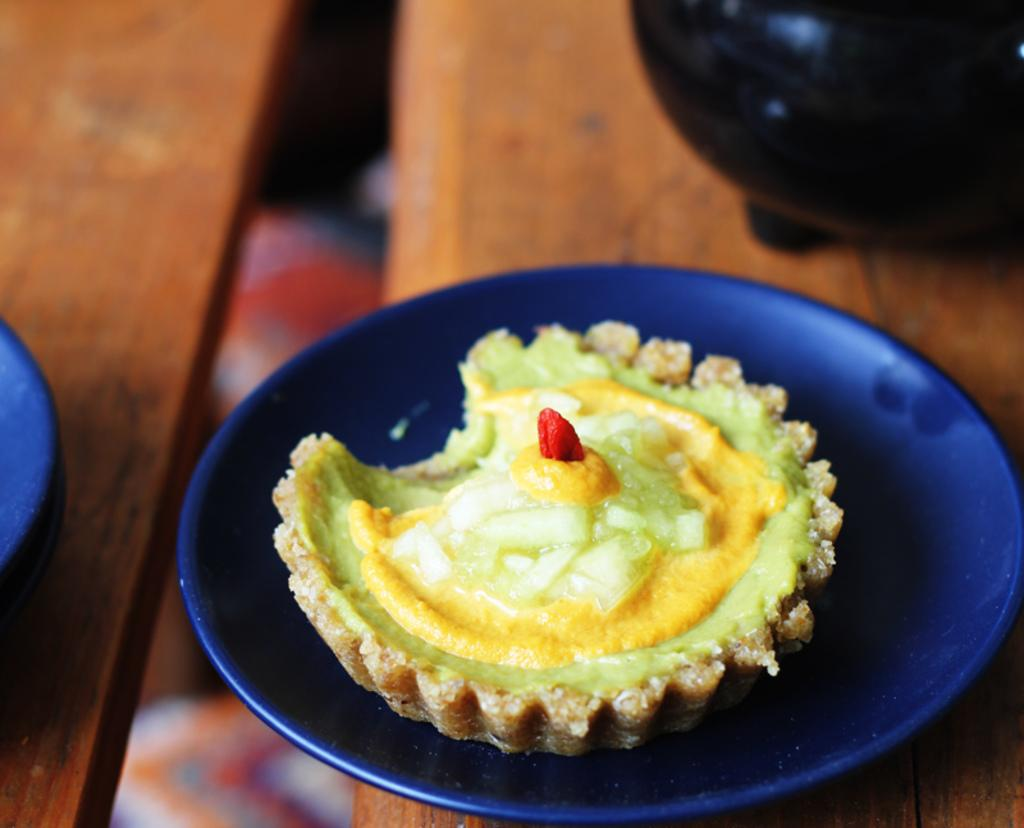What is the main structure visible in the image? There is a platform in the image. What is placed on the platform? There is food in a blue plate on the platform. Are there any other objects present on the platform besides the blue plate? Yes, there are other objects present on the platform. Can you see any steam coming from the food on the platform? There is no mention of steam in the image, so it cannot be determined if steam is present. What type of event is taking place on the platform? There is no indication of an event taking place in the image. 